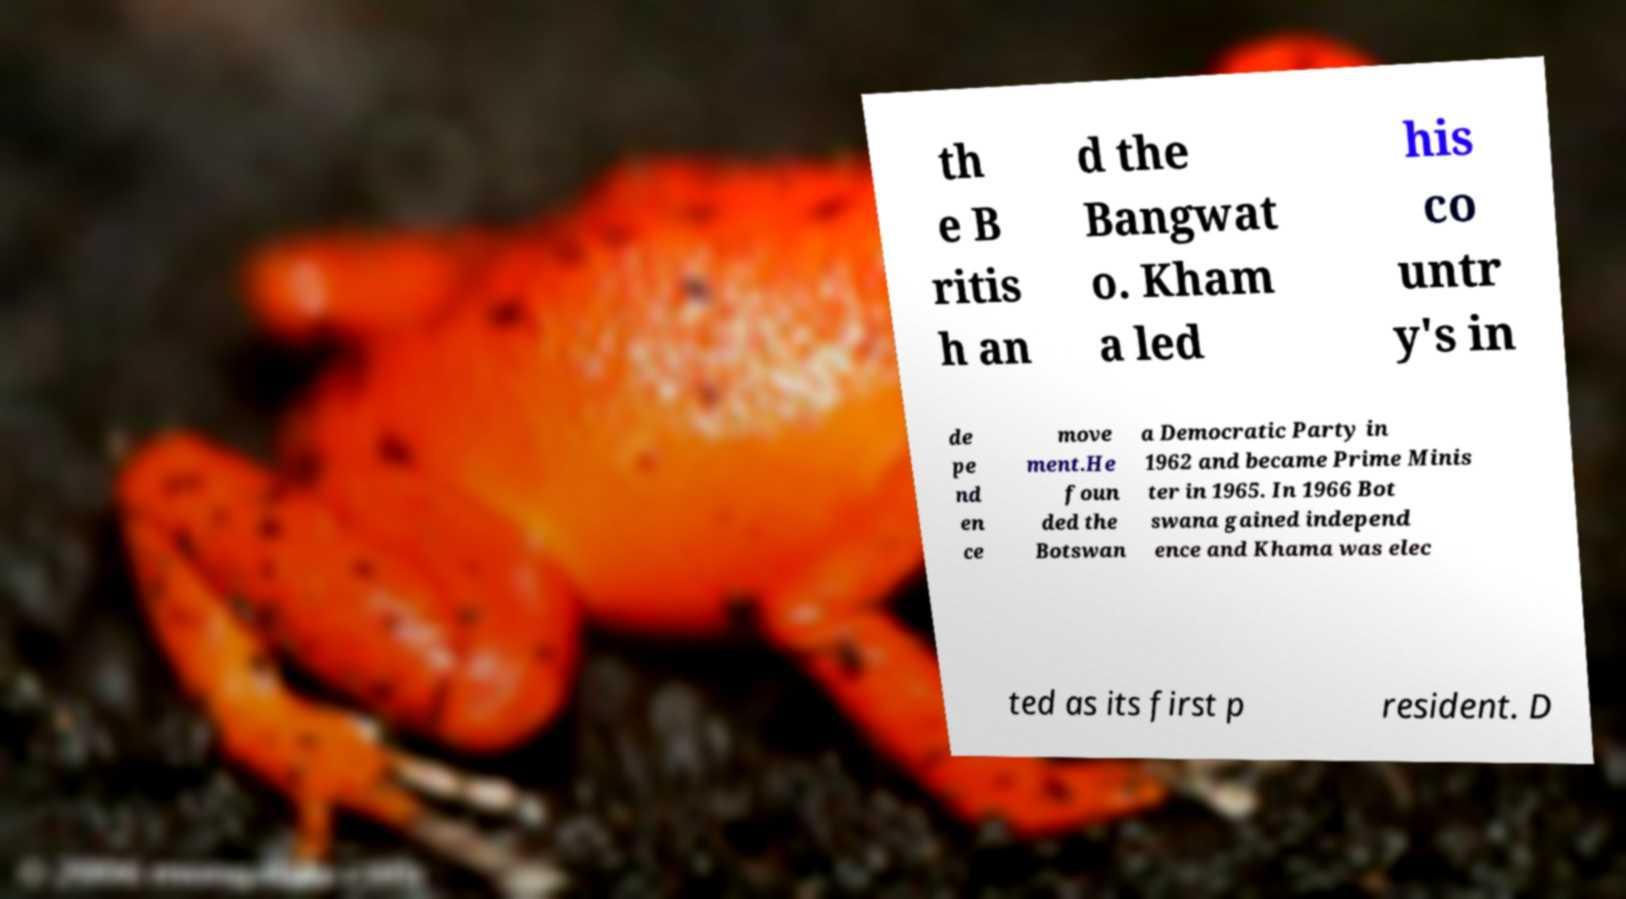For documentation purposes, I need the text within this image transcribed. Could you provide that? th e B ritis h an d the Bangwat o. Kham a led his co untr y's in de pe nd en ce move ment.He foun ded the Botswan a Democratic Party in 1962 and became Prime Minis ter in 1965. In 1966 Bot swana gained independ ence and Khama was elec ted as its first p resident. D 